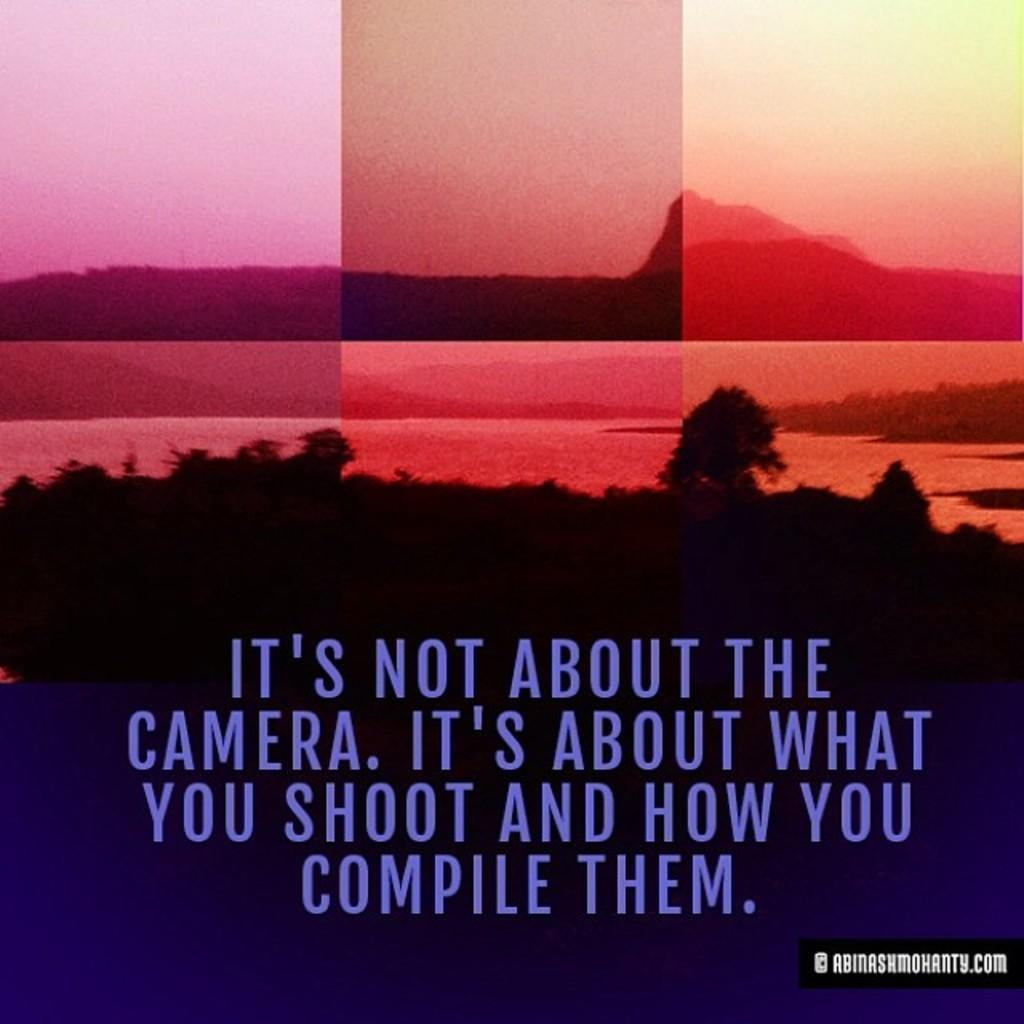<image>
Relay a brief, clear account of the picture shown. A sunset with the quote it's not about the camera, it's about what you shoot and how you compile them. 